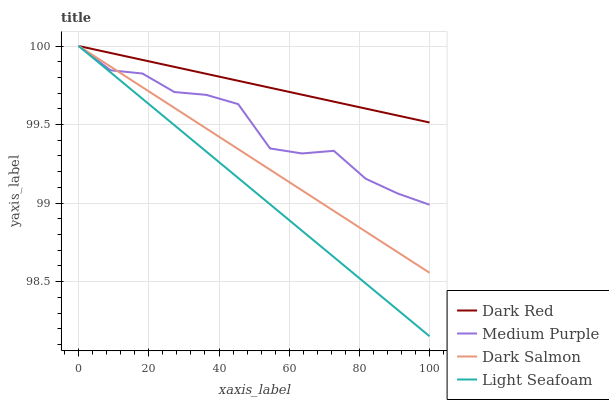Does Light Seafoam have the minimum area under the curve?
Answer yes or no. Yes. Does Dark Red have the maximum area under the curve?
Answer yes or no. Yes. Does Dark Red have the minimum area under the curve?
Answer yes or no. No. Does Light Seafoam have the maximum area under the curve?
Answer yes or no. No. Is Dark Red the smoothest?
Answer yes or no. Yes. Is Medium Purple the roughest?
Answer yes or no. Yes. Is Light Seafoam the smoothest?
Answer yes or no. No. Is Light Seafoam the roughest?
Answer yes or no. No. Does Light Seafoam have the lowest value?
Answer yes or no. Yes. Does Dark Red have the lowest value?
Answer yes or no. No. Does Dark Salmon have the highest value?
Answer yes or no. Yes. Does Medium Purple intersect Light Seafoam?
Answer yes or no. Yes. Is Medium Purple less than Light Seafoam?
Answer yes or no. No. Is Medium Purple greater than Light Seafoam?
Answer yes or no. No. 